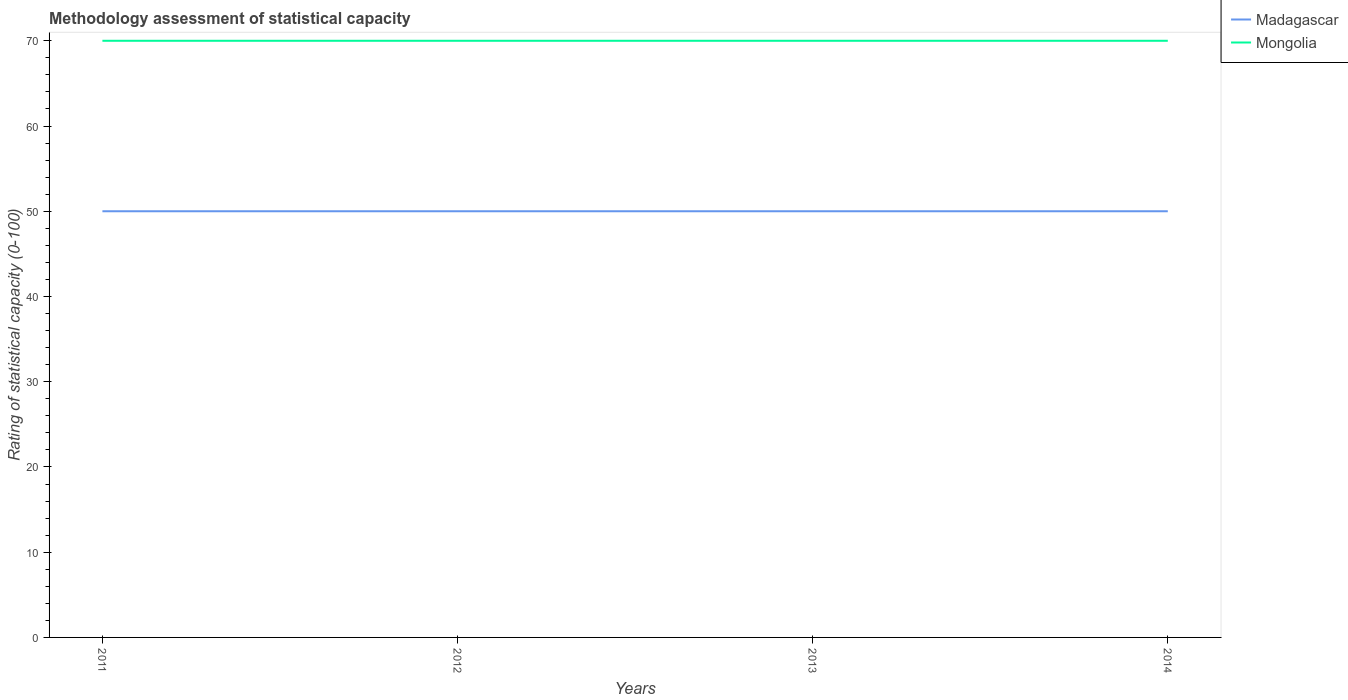How many different coloured lines are there?
Your answer should be very brief. 2. Does the line corresponding to Madagascar intersect with the line corresponding to Mongolia?
Give a very brief answer. No. Is the number of lines equal to the number of legend labels?
Ensure brevity in your answer.  Yes. Across all years, what is the maximum rating of statistical capacity in Madagascar?
Provide a short and direct response. 50. In which year was the rating of statistical capacity in Mongolia maximum?
Offer a terse response. 2011. What is the total rating of statistical capacity in Madagascar in the graph?
Provide a short and direct response. 0. What is the difference between the highest and the second highest rating of statistical capacity in Mongolia?
Your response must be concise. 0. What is the difference between the highest and the lowest rating of statistical capacity in Mongolia?
Your answer should be very brief. 0. Is the rating of statistical capacity in Mongolia strictly greater than the rating of statistical capacity in Madagascar over the years?
Provide a succinct answer. No. How many lines are there?
Offer a very short reply. 2. How many years are there in the graph?
Your answer should be compact. 4. Are the values on the major ticks of Y-axis written in scientific E-notation?
Provide a short and direct response. No. Where does the legend appear in the graph?
Provide a succinct answer. Top right. How many legend labels are there?
Your answer should be compact. 2. What is the title of the graph?
Offer a terse response. Methodology assessment of statistical capacity. What is the label or title of the X-axis?
Keep it short and to the point. Years. What is the label or title of the Y-axis?
Give a very brief answer. Rating of statistical capacity (0-100). What is the Rating of statistical capacity (0-100) in Madagascar in 2011?
Make the answer very short. 50. What is the Rating of statistical capacity (0-100) in Mongolia in 2011?
Make the answer very short. 70. What is the Rating of statistical capacity (0-100) in Madagascar in 2014?
Your response must be concise. 50. What is the Rating of statistical capacity (0-100) of Mongolia in 2014?
Your answer should be very brief. 70. Across all years, what is the minimum Rating of statistical capacity (0-100) of Madagascar?
Your answer should be compact. 50. What is the total Rating of statistical capacity (0-100) in Madagascar in the graph?
Provide a short and direct response. 200. What is the total Rating of statistical capacity (0-100) in Mongolia in the graph?
Provide a succinct answer. 280. What is the difference between the Rating of statistical capacity (0-100) of Madagascar in 2011 and that in 2012?
Provide a succinct answer. 0. What is the difference between the Rating of statistical capacity (0-100) in Mongolia in 2011 and that in 2012?
Keep it short and to the point. 0. What is the difference between the Rating of statistical capacity (0-100) of Madagascar in 2012 and that in 2014?
Ensure brevity in your answer.  0. What is the difference between the Rating of statistical capacity (0-100) in Madagascar in 2013 and that in 2014?
Offer a very short reply. 0. What is the difference between the Rating of statistical capacity (0-100) of Madagascar in 2011 and the Rating of statistical capacity (0-100) of Mongolia in 2012?
Make the answer very short. -20. In the year 2011, what is the difference between the Rating of statistical capacity (0-100) in Madagascar and Rating of statistical capacity (0-100) in Mongolia?
Offer a very short reply. -20. What is the ratio of the Rating of statistical capacity (0-100) in Madagascar in 2011 to that in 2012?
Offer a very short reply. 1. What is the ratio of the Rating of statistical capacity (0-100) in Mongolia in 2011 to that in 2014?
Provide a short and direct response. 1. What is the ratio of the Rating of statistical capacity (0-100) of Madagascar in 2012 to that in 2014?
Make the answer very short. 1. What is the difference between the highest and the lowest Rating of statistical capacity (0-100) of Madagascar?
Your answer should be compact. 0. What is the difference between the highest and the lowest Rating of statistical capacity (0-100) of Mongolia?
Keep it short and to the point. 0. 